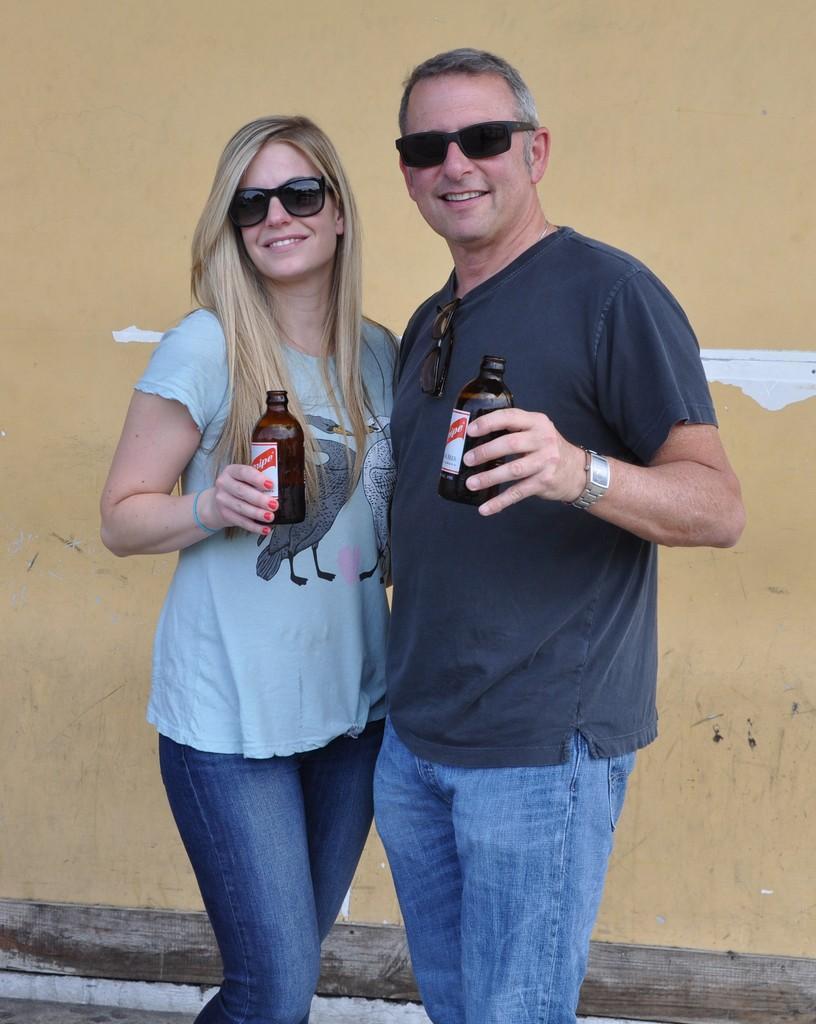Please provide a concise description of this image. In the picture we can see man and woman wearing goggles standing together and holding some bottles in their hands and in the background there is a wall. 